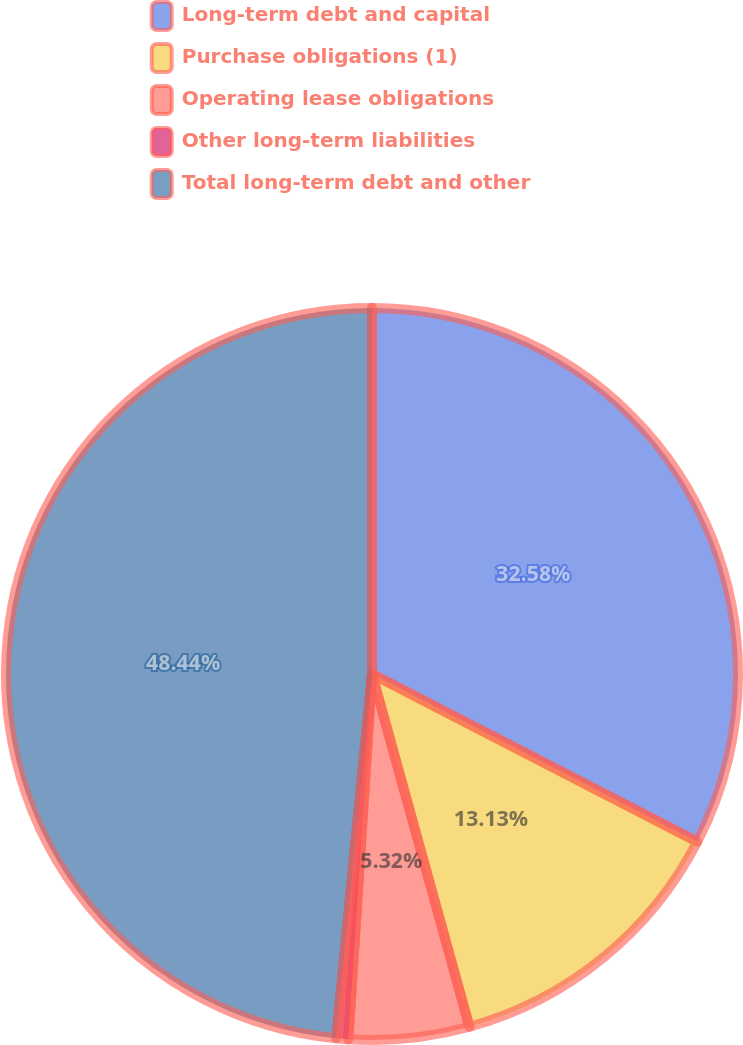Convert chart to OTSL. <chart><loc_0><loc_0><loc_500><loc_500><pie_chart><fcel>Long-term debt and capital<fcel>Purchase obligations (1)<fcel>Operating lease obligations<fcel>Other long-term liabilities<fcel>Total long-term debt and other<nl><fcel>32.58%<fcel>13.13%<fcel>5.32%<fcel>0.53%<fcel>48.44%<nl></chart> 